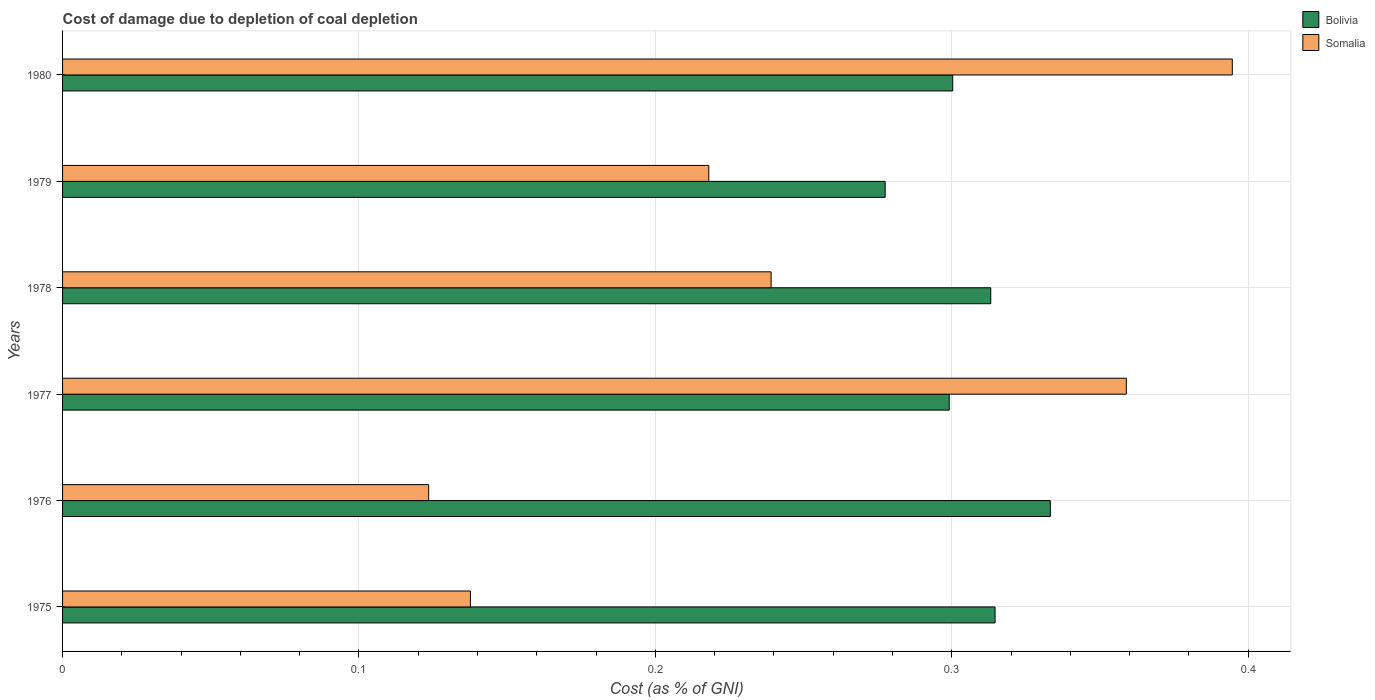How many groups of bars are there?
Make the answer very short. 6. Are the number of bars per tick equal to the number of legend labels?
Offer a terse response. Yes. How many bars are there on the 6th tick from the bottom?
Ensure brevity in your answer.  2. What is the label of the 5th group of bars from the top?
Give a very brief answer. 1976. In how many cases, is the number of bars for a given year not equal to the number of legend labels?
Give a very brief answer. 0. What is the cost of damage caused due to coal depletion in Bolivia in 1975?
Give a very brief answer. 0.31. Across all years, what is the maximum cost of damage caused due to coal depletion in Somalia?
Give a very brief answer. 0.39. Across all years, what is the minimum cost of damage caused due to coal depletion in Somalia?
Ensure brevity in your answer.  0.12. In which year was the cost of damage caused due to coal depletion in Bolivia maximum?
Your answer should be compact. 1976. In which year was the cost of damage caused due to coal depletion in Bolivia minimum?
Make the answer very short. 1979. What is the total cost of damage caused due to coal depletion in Somalia in the graph?
Offer a very short reply. 1.47. What is the difference between the cost of damage caused due to coal depletion in Bolivia in 1975 and that in 1977?
Provide a short and direct response. 0.02. What is the difference between the cost of damage caused due to coal depletion in Somalia in 1980 and the cost of damage caused due to coal depletion in Bolivia in 1978?
Provide a succinct answer. 0.08. What is the average cost of damage caused due to coal depletion in Bolivia per year?
Offer a very short reply. 0.31. In the year 1976, what is the difference between the cost of damage caused due to coal depletion in Bolivia and cost of damage caused due to coal depletion in Somalia?
Make the answer very short. 0.21. What is the ratio of the cost of damage caused due to coal depletion in Bolivia in 1976 to that in 1980?
Offer a very short reply. 1.11. Is the difference between the cost of damage caused due to coal depletion in Bolivia in 1978 and 1979 greater than the difference between the cost of damage caused due to coal depletion in Somalia in 1978 and 1979?
Make the answer very short. Yes. What is the difference between the highest and the second highest cost of damage caused due to coal depletion in Bolivia?
Your answer should be very brief. 0.02. What is the difference between the highest and the lowest cost of damage caused due to coal depletion in Somalia?
Provide a succinct answer. 0.27. In how many years, is the cost of damage caused due to coal depletion in Somalia greater than the average cost of damage caused due to coal depletion in Somalia taken over all years?
Make the answer very short. 2. Is the sum of the cost of damage caused due to coal depletion in Somalia in 1975 and 1978 greater than the maximum cost of damage caused due to coal depletion in Bolivia across all years?
Ensure brevity in your answer.  Yes. What does the 1st bar from the top in 1979 represents?
Ensure brevity in your answer.  Somalia. What does the 1st bar from the bottom in 1977 represents?
Offer a terse response. Bolivia. Are all the bars in the graph horizontal?
Make the answer very short. Yes. How many years are there in the graph?
Your answer should be compact. 6. Are the values on the major ticks of X-axis written in scientific E-notation?
Provide a succinct answer. No. Where does the legend appear in the graph?
Ensure brevity in your answer.  Top right. What is the title of the graph?
Your answer should be compact. Cost of damage due to depletion of coal depletion. What is the label or title of the X-axis?
Provide a succinct answer. Cost (as % of GNI). What is the label or title of the Y-axis?
Your answer should be compact. Years. What is the Cost (as % of GNI) of Bolivia in 1975?
Make the answer very short. 0.31. What is the Cost (as % of GNI) in Somalia in 1975?
Keep it short and to the point. 0.14. What is the Cost (as % of GNI) of Bolivia in 1976?
Your response must be concise. 0.33. What is the Cost (as % of GNI) in Somalia in 1976?
Your answer should be compact. 0.12. What is the Cost (as % of GNI) in Bolivia in 1977?
Offer a terse response. 0.3. What is the Cost (as % of GNI) of Somalia in 1977?
Make the answer very short. 0.36. What is the Cost (as % of GNI) of Bolivia in 1978?
Offer a very short reply. 0.31. What is the Cost (as % of GNI) in Somalia in 1978?
Offer a very short reply. 0.24. What is the Cost (as % of GNI) of Bolivia in 1979?
Your answer should be very brief. 0.28. What is the Cost (as % of GNI) in Somalia in 1979?
Give a very brief answer. 0.22. What is the Cost (as % of GNI) of Bolivia in 1980?
Your answer should be compact. 0.3. What is the Cost (as % of GNI) in Somalia in 1980?
Ensure brevity in your answer.  0.39. Across all years, what is the maximum Cost (as % of GNI) of Bolivia?
Keep it short and to the point. 0.33. Across all years, what is the maximum Cost (as % of GNI) in Somalia?
Make the answer very short. 0.39. Across all years, what is the minimum Cost (as % of GNI) in Bolivia?
Provide a succinct answer. 0.28. Across all years, what is the minimum Cost (as % of GNI) in Somalia?
Provide a succinct answer. 0.12. What is the total Cost (as % of GNI) in Bolivia in the graph?
Give a very brief answer. 1.84. What is the total Cost (as % of GNI) in Somalia in the graph?
Make the answer very short. 1.47. What is the difference between the Cost (as % of GNI) of Bolivia in 1975 and that in 1976?
Make the answer very short. -0.02. What is the difference between the Cost (as % of GNI) of Somalia in 1975 and that in 1976?
Your answer should be compact. 0.01. What is the difference between the Cost (as % of GNI) of Bolivia in 1975 and that in 1977?
Offer a terse response. 0.02. What is the difference between the Cost (as % of GNI) of Somalia in 1975 and that in 1977?
Keep it short and to the point. -0.22. What is the difference between the Cost (as % of GNI) in Bolivia in 1975 and that in 1978?
Your answer should be very brief. 0. What is the difference between the Cost (as % of GNI) in Somalia in 1975 and that in 1978?
Provide a succinct answer. -0.1. What is the difference between the Cost (as % of GNI) in Bolivia in 1975 and that in 1979?
Offer a very short reply. 0.04. What is the difference between the Cost (as % of GNI) in Somalia in 1975 and that in 1979?
Provide a succinct answer. -0.08. What is the difference between the Cost (as % of GNI) in Bolivia in 1975 and that in 1980?
Your answer should be compact. 0.01. What is the difference between the Cost (as % of GNI) of Somalia in 1975 and that in 1980?
Make the answer very short. -0.26. What is the difference between the Cost (as % of GNI) in Bolivia in 1976 and that in 1977?
Your response must be concise. 0.03. What is the difference between the Cost (as % of GNI) in Somalia in 1976 and that in 1977?
Make the answer very short. -0.24. What is the difference between the Cost (as % of GNI) in Bolivia in 1976 and that in 1978?
Your response must be concise. 0.02. What is the difference between the Cost (as % of GNI) of Somalia in 1976 and that in 1978?
Keep it short and to the point. -0.12. What is the difference between the Cost (as % of GNI) of Bolivia in 1976 and that in 1979?
Give a very brief answer. 0.06. What is the difference between the Cost (as % of GNI) of Somalia in 1976 and that in 1979?
Make the answer very short. -0.09. What is the difference between the Cost (as % of GNI) in Bolivia in 1976 and that in 1980?
Keep it short and to the point. 0.03. What is the difference between the Cost (as % of GNI) in Somalia in 1976 and that in 1980?
Your answer should be compact. -0.27. What is the difference between the Cost (as % of GNI) of Bolivia in 1977 and that in 1978?
Make the answer very short. -0.01. What is the difference between the Cost (as % of GNI) of Somalia in 1977 and that in 1978?
Offer a very short reply. 0.12. What is the difference between the Cost (as % of GNI) in Bolivia in 1977 and that in 1979?
Your answer should be compact. 0.02. What is the difference between the Cost (as % of GNI) of Somalia in 1977 and that in 1979?
Your response must be concise. 0.14. What is the difference between the Cost (as % of GNI) of Bolivia in 1977 and that in 1980?
Offer a terse response. -0. What is the difference between the Cost (as % of GNI) of Somalia in 1977 and that in 1980?
Your answer should be compact. -0.04. What is the difference between the Cost (as % of GNI) of Bolivia in 1978 and that in 1979?
Make the answer very short. 0.04. What is the difference between the Cost (as % of GNI) in Somalia in 1978 and that in 1979?
Ensure brevity in your answer.  0.02. What is the difference between the Cost (as % of GNI) in Bolivia in 1978 and that in 1980?
Your answer should be compact. 0.01. What is the difference between the Cost (as % of GNI) of Somalia in 1978 and that in 1980?
Provide a short and direct response. -0.16. What is the difference between the Cost (as % of GNI) of Bolivia in 1979 and that in 1980?
Ensure brevity in your answer.  -0.02. What is the difference between the Cost (as % of GNI) of Somalia in 1979 and that in 1980?
Give a very brief answer. -0.18. What is the difference between the Cost (as % of GNI) of Bolivia in 1975 and the Cost (as % of GNI) of Somalia in 1976?
Give a very brief answer. 0.19. What is the difference between the Cost (as % of GNI) in Bolivia in 1975 and the Cost (as % of GNI) in Somalia in 1977?
Your answer should be very brief. -0.04. What is the difference between the Cost (as % of GNI) of Bolivia in 1975 and the Cost (as % of GNI) of Somalia in 1978?
Offer a terse response. 0.08. What is the difference between the Cost (as % of GNI) of Bolivia in 1975 and the Cost (as % of GNI) of Somalia in 1979?
Offer a terse response. 0.1. What is the difference between the Cost (as % of GNI) in Bolivia in 1975 and the Cost (as % of GNI) in Somalia in 1980?
Give a very brief answer. -0.08. What is the difference between the Cost (as % of GNI) of Bolivia in 1976 and the Cost (as % of GNI) of Somalia in 1977?
Offer a very short reply. -0.03. What is the difference between the Cost (as % of GNI) in Bolivia in 1976 and the Cost (as % of GNI) in Somalia in 1978?
Provide a succinct answer. 0.09. What is the difference between the Cost (as % of GNI) of Bolivia in 1976 and the Cost (as % of GNI) of Somalia in 1979?
Give a very brief answer. 0.12. What is the difference between the Cost (as % of GNI) in Bolivia in 1976 and the Cost (as % of GNI) in Somalia in 1980?
Make the answer very short. -0.06. What is the difference between the Cost (as % of GNI) of Bolivia in 1977 and the Cost (as % of GNI) of Somalia in 1978?
Provide a short and direct response. 0.06. What is the difference between the Cost (as % of GNI) in Bolivia in 1977 and the Cost (as % of GNI) in Somalia in 1979?
Your answer should be very brief. 0.08. What is the difference between the Cost (as % of GNI) in Bolivia in 1977 and the Cost (as % of GNI) in Somalia in 1980?
Offer a very short reply. -0.1. What is the difference between the Cost (as % of GNI) in Bolivia in 1978 and the Cost (as % of GNI) in Somalia in 1979?
Provide a succinct answer. 0.1. What is the difference between the Cost (as % of GNI) of Bolivia in 1978 and the Cost (as % of GNI) of Somalia in 1980?
Provide a succinct answer. -0.08. What is the difference between the Cost (as % of GNI) in Bolivia in 1979 and the Cost (as % of GNI) in Somalia in 1980?
Provide a succinct answer. -0.12. What is the average Cost (as % of GNI) in Bolivia per year?
Your answer should be very brief. 0.31. What is the average Cost (as % of GNI) in Somalia per year?
Offer a terse response. 0.25. In the year 1975, what is the difference between the Cost (as % of GNI) of Bolivia and Cost (as % of GNI) of Somalia?
Ensure brevity in your answer.  0.18. In the year 1976, what is the difference between the Cost (as % of GNI) in Bolivia and Cost (as % of GNI) in Somalia?
Make the answer very short. 0.21. In the year 1977, what is the difference between the Cost (as % of GNI) of Bolivia and Cost (as % of GNI) of Somalia?
Offer a very short reply. -0.06. In the year 1978, what is the difference between the Cost (as % of GNI) of Bolivia and Cost (as % of GNI) of Somalia?
Your response must be concise. 0.07. In the year 1979, what is the difference between the Cost (as % of GNI) in Bolivia and Cost (as % of GNI) in Somalia?
Offer a very short reply. 0.06. In the year 1980, what is the difference between the Cost (as % of GNI) of Bolivia and Cost (as % of GNI) of Somalia?
Offer a terse response. -0.09. What is the ratio of the Cost (as % of GNI) in Bolivia in 1975 to that in 1976?
Keep it short and to the point. 0.94. What is the ratio of the Cost (as % of GNI) in Somalia in 1975 to that in 1976?
Your answer should be compact. 1.11. What is the ratio of the Cost (as % of GNI) in Bolivia in 1975 to that in 1977?
Provide a succinct answer. 1.05. What is the ratio of the Cost (as % of GNI) in Somalia in 1975 to that in 1977?
Ensure brevity in your answer.  0.38. What is the ratio of the Cost (as % of GNI) in Bolivia in 1975 to that in 1978?
Your answer should be compact. 1. What is the ratio of the Cost (as % of GNI) of Somalia in 1975 to that in 1978?
Make the answer very short. 0.58. What is the ratio of the Cost (as % of GNI) of Bolivia in 1975 to that in 1979?
Offer a very short reply. 1.13. What is the ratio of the Cost (as % of GNI) in Somalia in 1975 to that in 1979?
Provide a succinct answer. 0.63. What is the ratio of the Cost (as % of GNI) in Bolivia in 1975 to that in 1980?
Your answer should be very brief. 1.05. What is the ratio of the Cost (as % of GNI) in Somalia in 1975 to that in 1980?
Provide a succinct answer. 0.35. What is the ratio of the Cost (as % of GNI) in Bolivia in 1976 to that in 1977?
Offer a terse response. 1.11. What is the ratio of the Cost (as % of GNI) of Somalia in 1976 to that in 1977?
Your answer should be very brief. 0.34. What is the ratio of the Cost (as % of GNI) of Bolivia in 1976 to that in 1978?
Provide a short and direct response. 1.06. What is the ratio of the Cost (as % of GNI) in Somalia in 1976 to that in 1978?
Offer a very short reply. 0.52. What is the ratio of the Cost (as % of GNI) of Bolivia in 1976 to that in 1979?
Provide a short and direct response. 1.2. What is the ratio of the Cost (as % of GNI) of Somalia in 1976 to that in 1979?
Provide a short and direct response. 0.57. What is the ratio of the Cost (as % of GNI) in Bolivia in 1976 to that in 1980?
Your answer should be compact. 1.11. What is the ratio of the Cost (as % of GNI) of Somalia in 1976 to that in 1980?
Ensure brevity in your answer.  0.31. What is the ratio of the Cost (as % of GNI) in Bolivia in 1977 to that in 1978?
Offer a very short reply. 0.96. What is the ratio of the Cost (as % of GNI) of Somalia in 1977 to that in 1978?
Your answer should be very brief. 1.5. What is the ratio of the Cost (as % of GNI) in Bolivia in 1977 to that in 1979?
Your answer should be very brief. 1.08. What is the ratio of the Cost (as % of GNI) in Somalia in 1977 to that in 1979?
Offer a very short reply. 1.65. What is the ratio of the Cost (as % of GNI) in Somalia in 1977 to that in 1980?
Offer a very short reply. 0.91. What is the ratio of the Cost (as % of GNI) in Bolivia in 1978 to that in 1979?
Offer a terse response. 1.13. What is the ratio of the Cost (as % of GNI) of Somalia in 1978 to that in 1979?
Provide a short and direct response. 1.1. What is the ratio of the Cost (as % of GNI) in Bolivia in 1978 to that in 1980?
Keep it short and to the point. 1.04. What is the ratio of the Cost (as % of GNI) in Somalia in 1978 to that in 1980?
Your answer should be compact. 0.61. What is the ratio of the Cost (as % of GNI) of Bolivia in 1979 to that in 1980?
Offer a very short reply. 0.92. What is the ratio of the Cost (as % of GNI) of Somalia in 1979 to that in 1980?
Offer a very short reply. 0.55. What is the difference between the highest and the second highest Cost (as % of GNI) in Bolivia?
Ensure brevity in your answer.  0.02. What is the difference between the highest and the second highest Cost (as % of GNI) in Somalia?
Make the answer very short. 0.04. What is the difference between the highest and the lowest Cost (as % of GNI) in Bolivia?
Offer a terse response. 0.06. What is the difference between the highest and the lowest Cost (as % of GNI) of Somalia?
Make the answer very short. 0.27. 